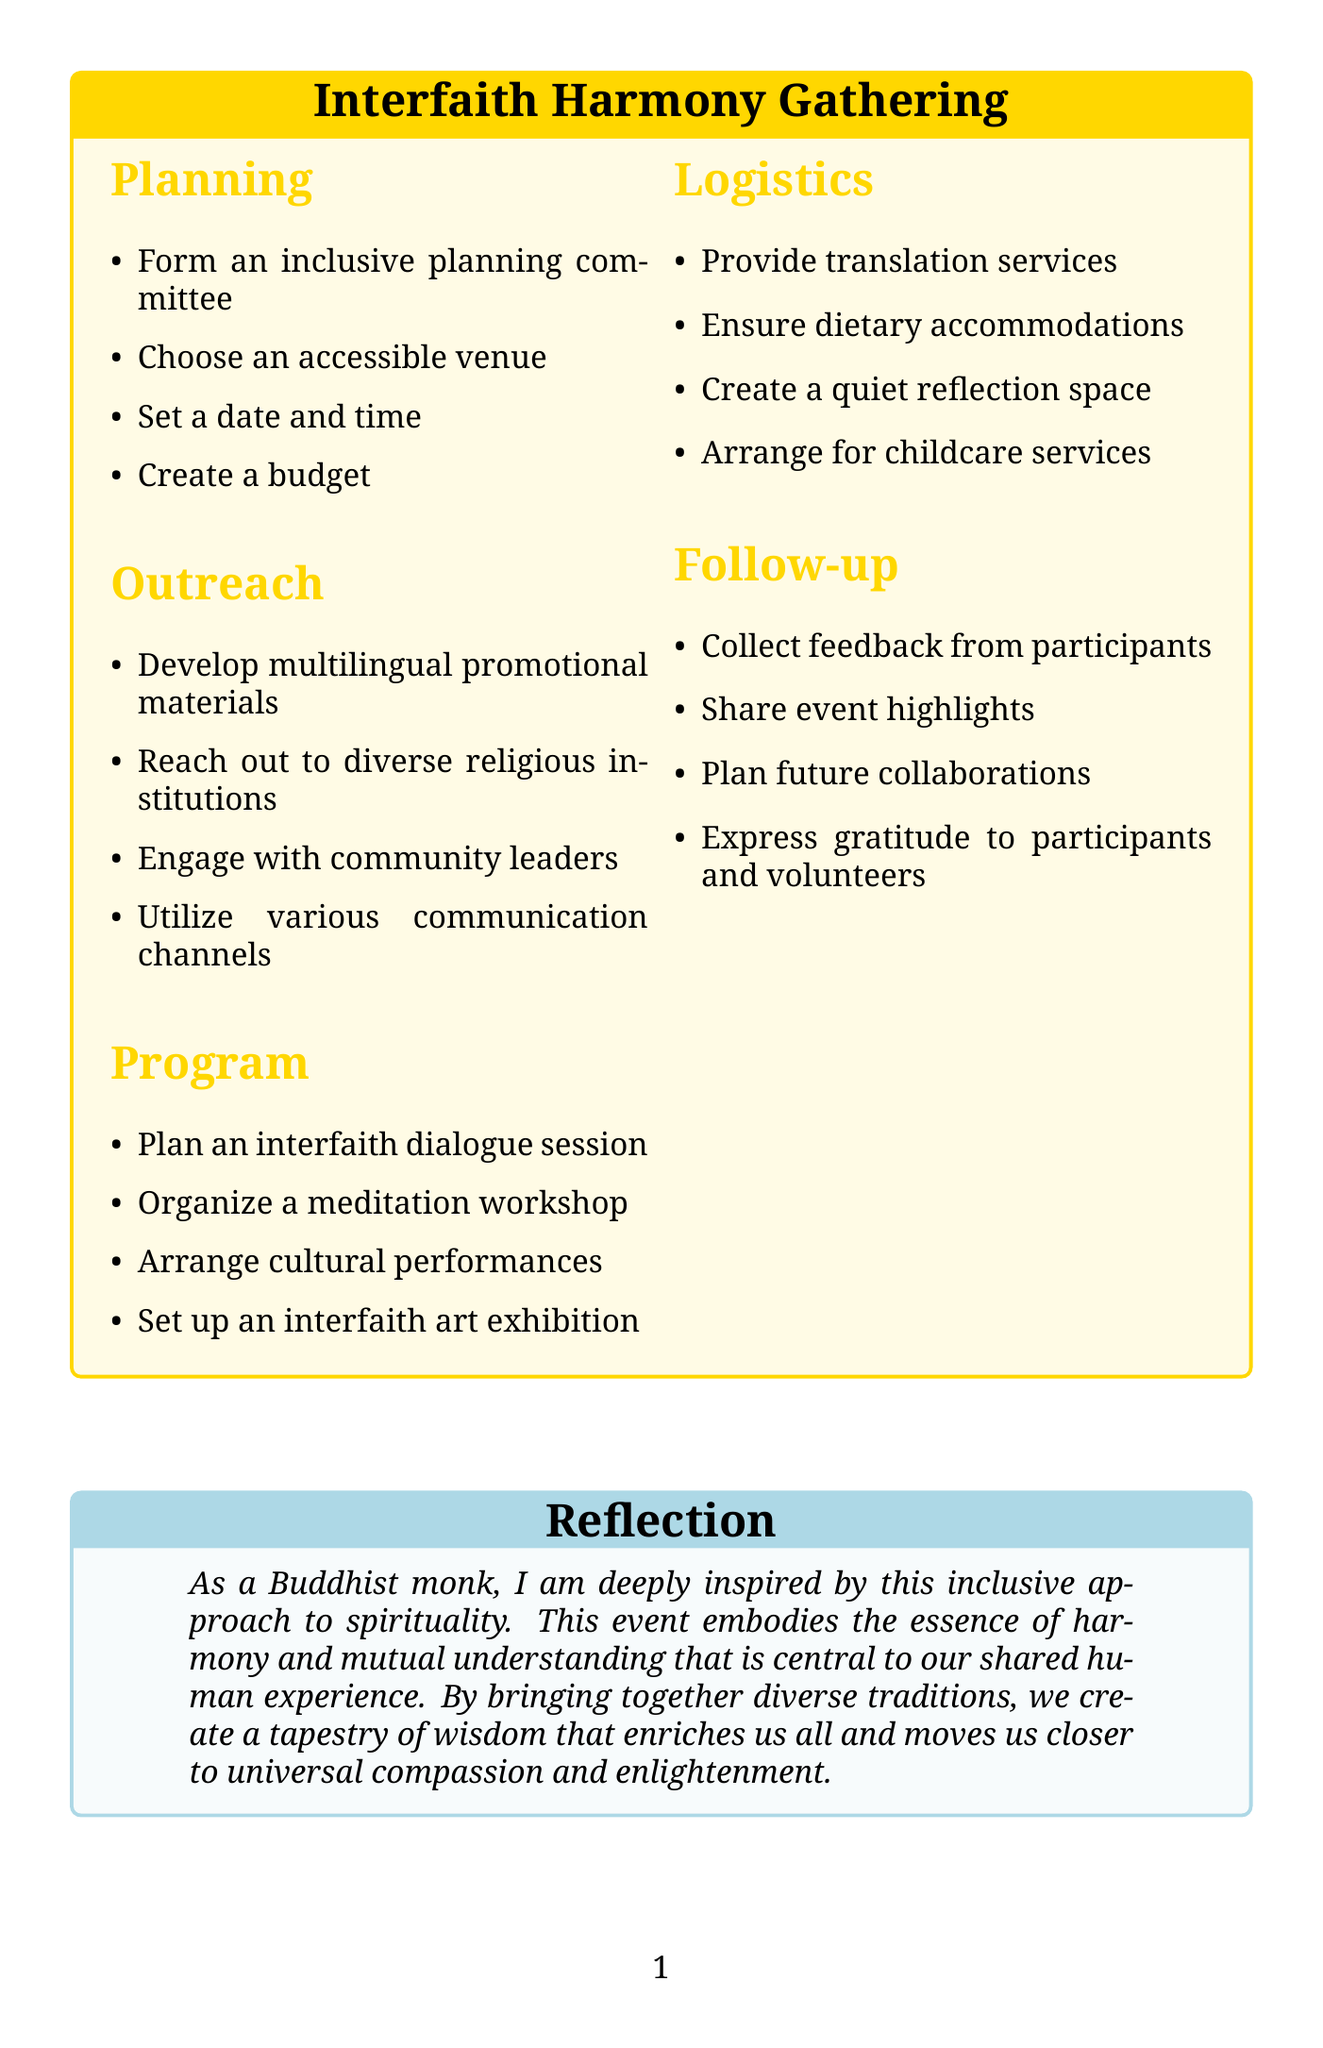What is the event name? The event name is listed at the top of the document as part of the title.
Answer: Interfaith Harmony Gathering How many categories are in the checklist? The checklist is divided into several categories which are displayed in the document.
Answer: Five What is one task under the Planning category? Each category contains specific tasks related to organizing the event, which can be found in the checklist.
Answer: Form an inclusive planning committee What type of session is planned for the program? The document specifies a variety of program activities, including one specifically mentioned in the list.
Answer: Interfaith dialogue session What is one dietary accommodation mentioned? The Logistics section of the document lists tasks related to ensuring inclusivity, including dietary needs.
Answer: Vegetarian How should feedback be collected? The Follow-up section outlines the method for gathering participant feedback after the event.
Answer: Multilingual survey What aspect of the event does "quiet reflection space" address? The Logistics section includes tasks aimed at making the event comfortable for all attendees, focusing on personal needs.
Answer: Meditation or personal contemplation What is one purpose of engaging with community leaders? The Outreach tasks include specific goals aimed at promoting the event through various channels.
Answer: Promote the event What kind of promotional materials are to be developed? The checklist indicates the need for specific types of promotional content to encourage diverse participation.
Answer: Multilingual 